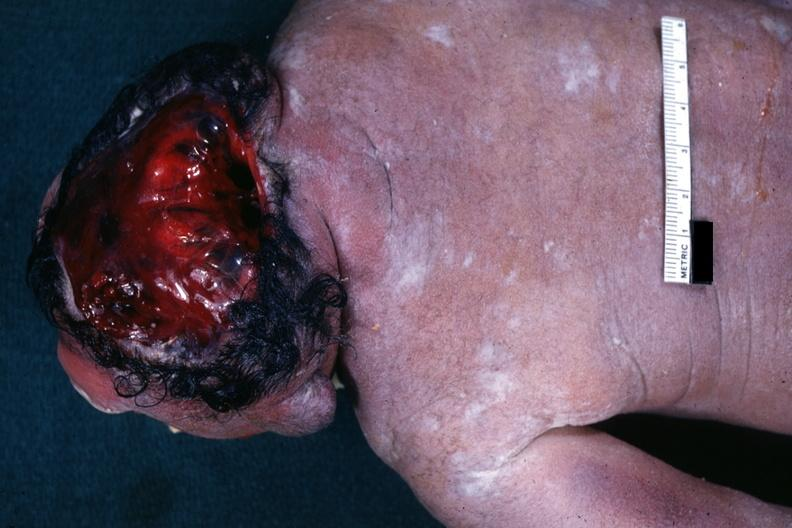does this image show view from back typical example?
Answer the question using a single word or phrase. Yes 